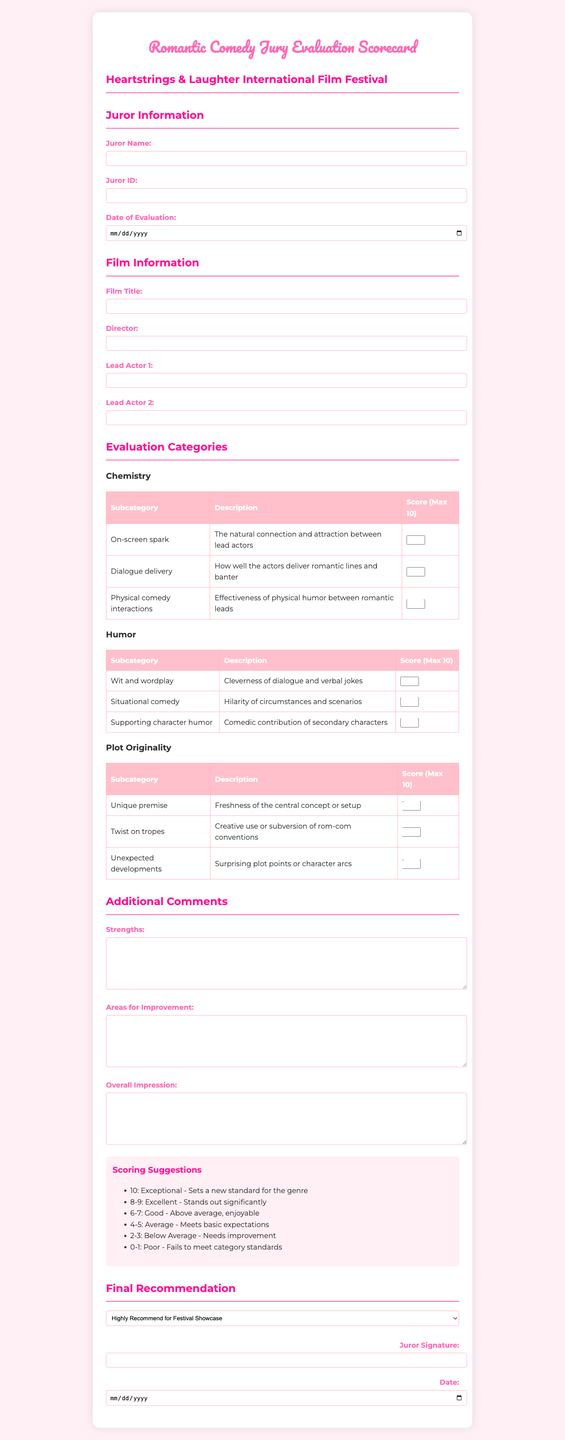what is the title of the form? The title of the form is found at the top of the document as stated in the title section.
Answer: Romantic Comedy Jury Evaluation Scorecard who is the festival associated with this form? The festival name is presented prominently in the document, indicating the event it is created for.
Answer: Heartstrings & Laughter International Film Festival how many subcategories are under the Chemistry category? The subcategories are listed under each evaluation category, and we need to count them specifically for Chemistry.
Answer: 3 what is the maximum score for the On-screen spark subcategory? Each subcategory lists its maximum score, specifically noting the On-screen spark subcategory within Chemistry.
Answer: 10 what type of humor is assessed in the Humor category? The Humor category includes different aspects listed in the subcategories, one of which relates to situations.
Answer: Situational comedy which recommendation option indicates the film should be considered for the festival showcase? The final recommendation section lists several options for jurors to choose from regarding the showcase.
Answer: Consider for Festival Showcase what is the date input format used for evaluations? The document specifies the type of input fields and their expected formats for dates.
Answer: Date how will jurors indicate their overall impression of the film? There is a specific section in the document where jurors can provide their thoughts and assessments in written form.
Answer: Text area what is the description for the Unique premise subcategory? Each subcategory contains descriptions that provide insight into what is being evaluated.
Answer: Freshness of the central concept or setup what is the score range suggestion for an average film? The scoring suggestions help jurors know how to rate films, particularly in the average category.
Answer: 4-5 